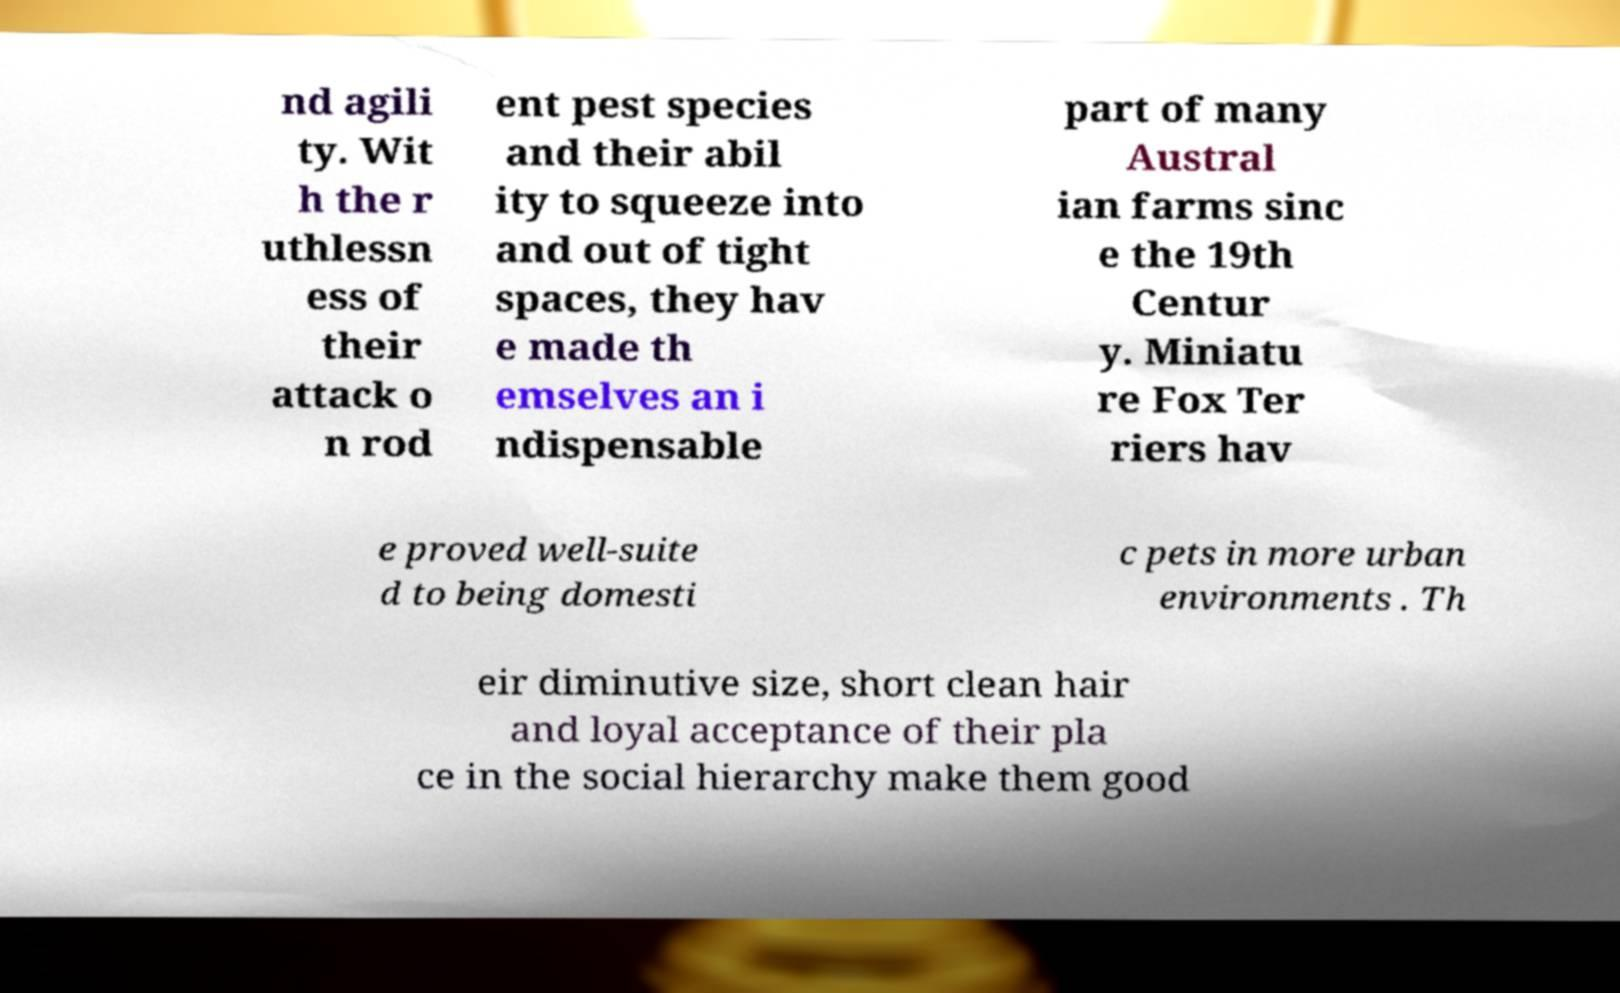Can you accurately transcribe the text from the provided image for me? nd agili ty. Wit h the r uthlessn ess of their attack o n rod ent pest species and their abil ity to squeeze into and out of tight spaces, they hav e made th emselves an i ndispensable part of many Austral ian farms sinc e the 19th Centur y. Miniatu re Fox Ter riers hav e proved well-suite d to being domesti c pets in more urban environments . Th eir diminutive size, short clean hair and loyal acceptance of their pla ce in the social hierarchy make them good 